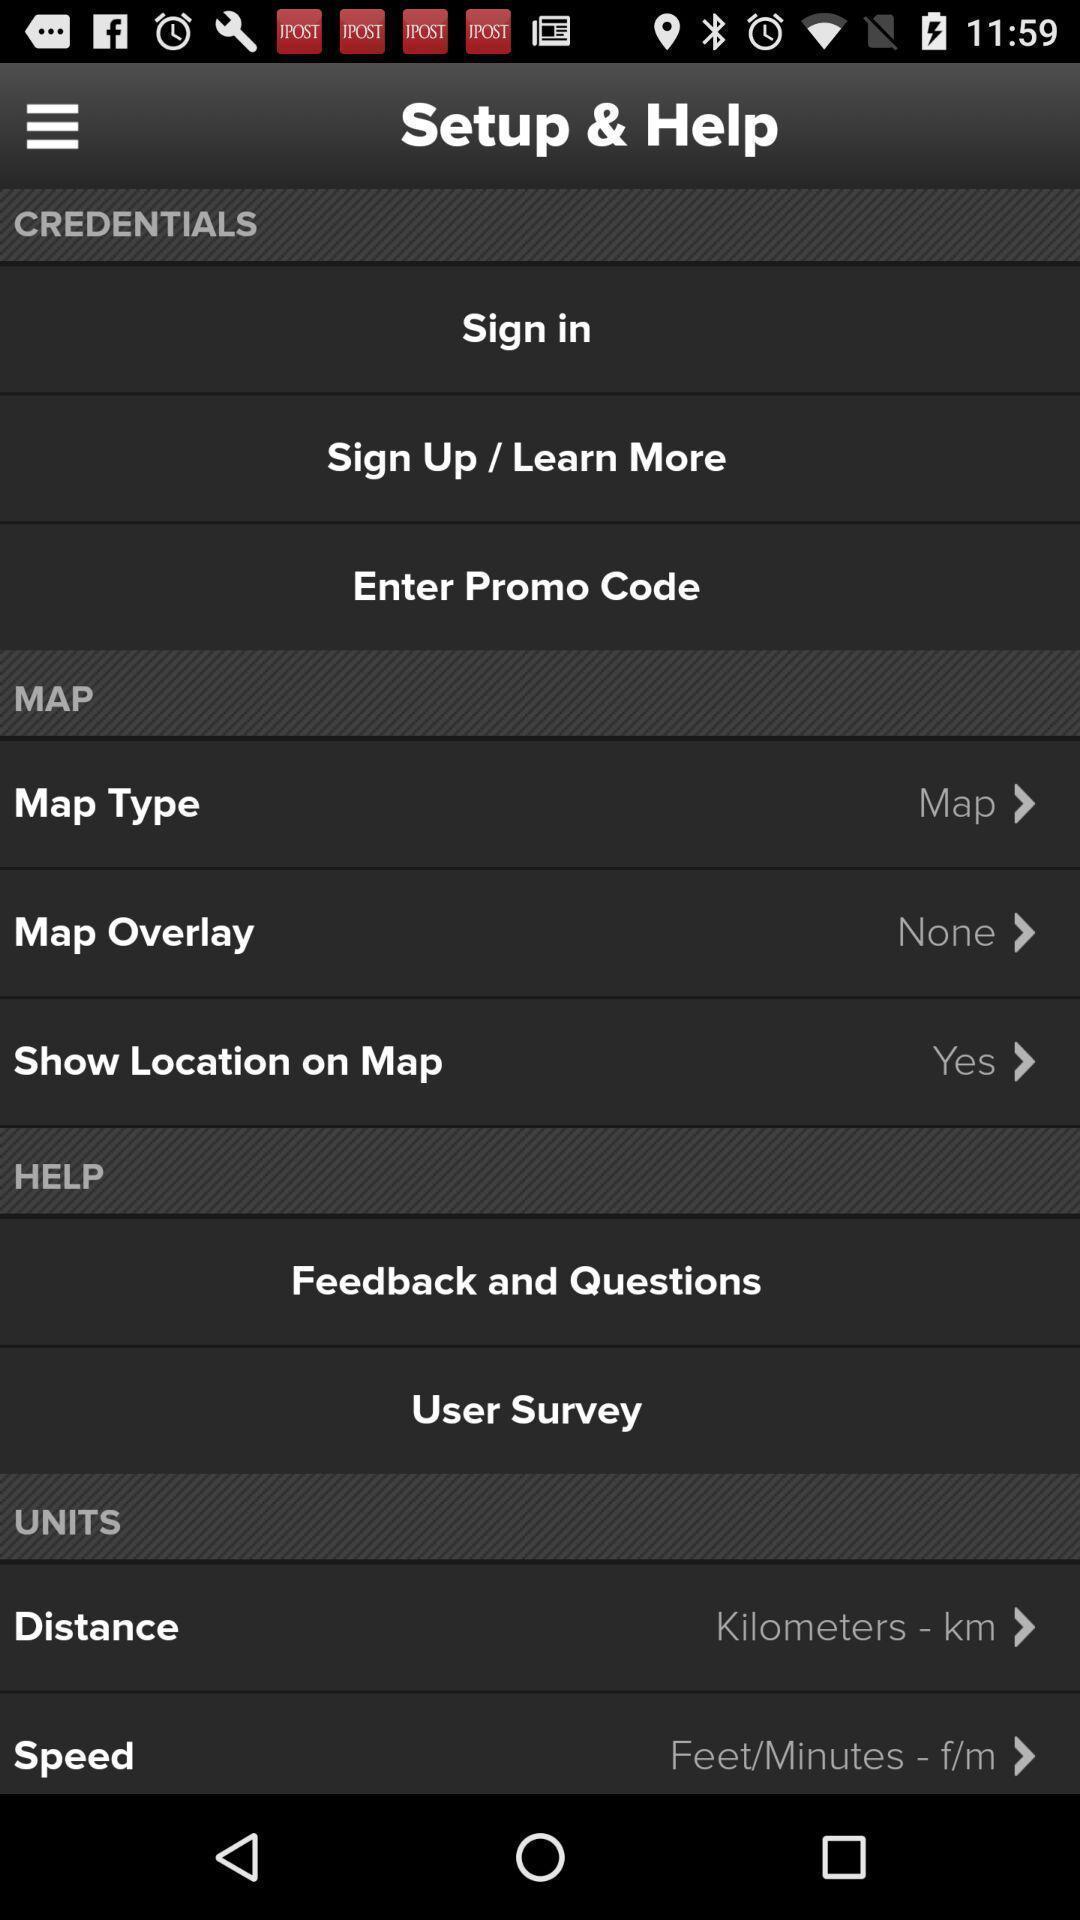What is the overall content of this screenshot? Screen shows to set up and survey. 